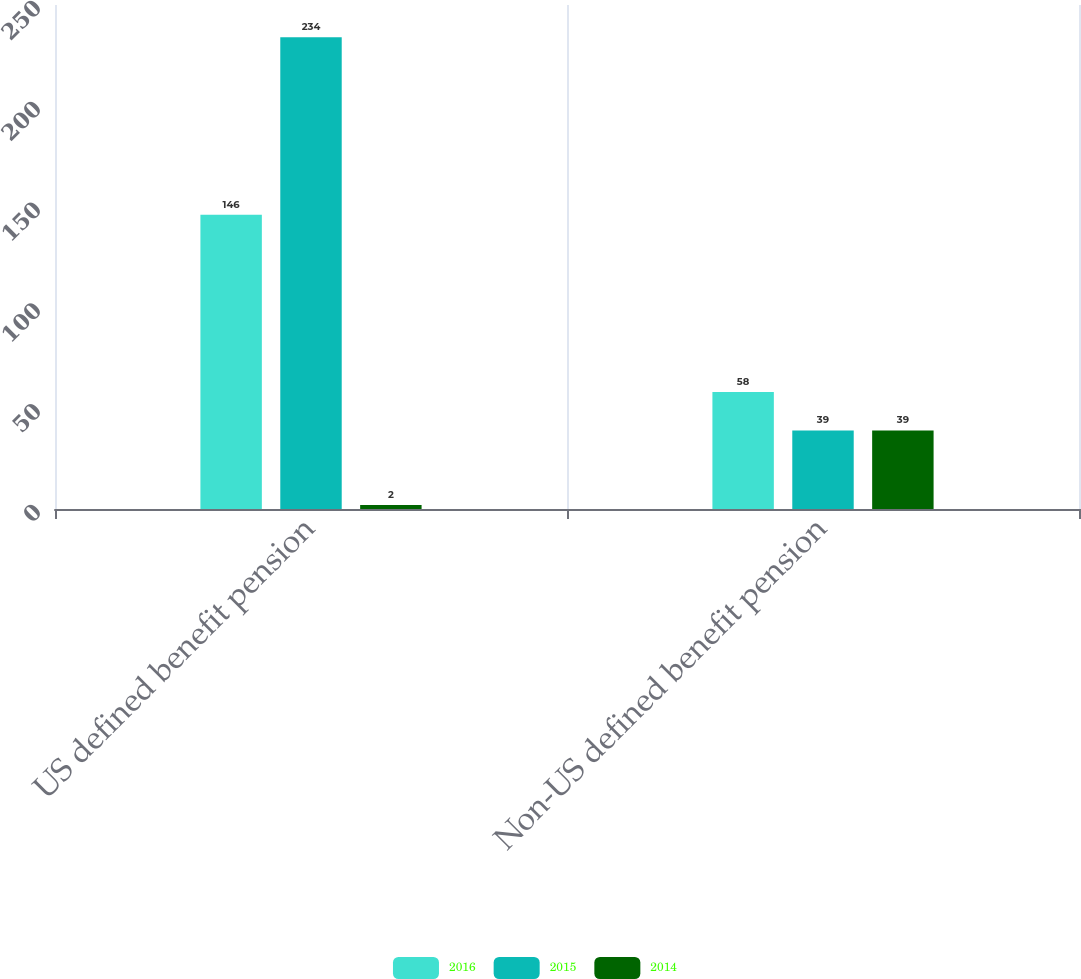Convert chart to OTSL. <chart><loc_0><loc_0><loc_500><loc_500><stacked_bar_chart><ecel><fcel>US defined benefit pension<fcel>Non-US defined benefit pension<nl><fcel>2016<fcel>146<fcel>58<nl><fcel>2015<fcel>234<fcel>39<nl><fcel>2014<fcel>2<fcel>39<nl></chart> 